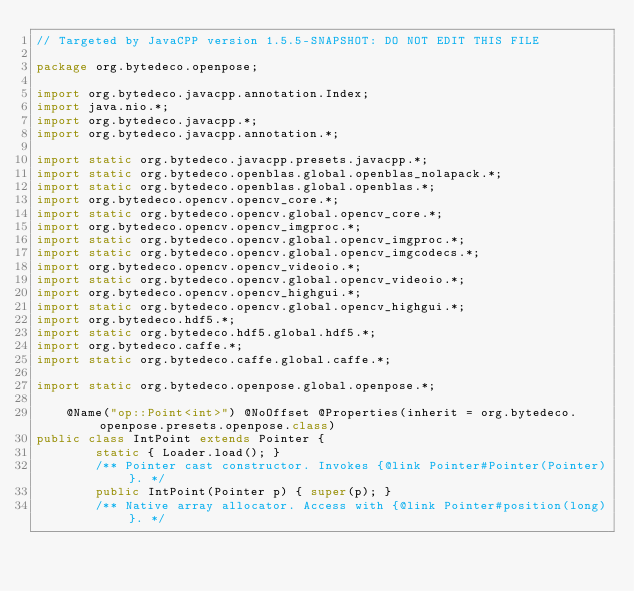Convert code to text. <code><loc_0><loc_0><loc_500><loc_500><_Java_>// Targeted by JavaCPP version 1.5.5-SNAPSHOT: DO NOT EDIT THIS FILE

package org.bytedeco.openpose;

import org.bytedeco.javacpp.annotation.Index;
import java.nio.*;
import org.bytedeco.javacpp.*;
import org.bytedeco.javacpp.annotation.*;

import static org.bytedeco.javacpp.presets.javacpp.*;
import static org.bytedeco.openblas.global.openblas_nolapack.*;
import static org.bytedeco.openblas.global.openblas.*;
import org.bytedeco.opencv.opencv_core.*;
import static org.bytedeco.opencv.global.opencv_core.*;
import org.bytedeco.opencv.opencv_imgproc.*;
import static org.bytedeco.opencv.global.opencv_imgproc.*;
import static org.bytedeco.opencv.global.opencv_imgcodecs.*;
import org.bytedeco.opencv.opencv_videoio.*;
import static org.bytedeco.opencv.global.opencv_videoio.*;
import org.bytedeco.opencv.opencv_highgui.*;
import static org.bytedeco.opencv.global.opencv_highgui.*;
import org.bytedeco.hdf5.*;
import static org.bytedeco.hdf5.global.hdf5.*;
import org.bytedeco.caffe.*;
import static org.bytedeco.caffe.global.caffe.*;

import static org.bytedeco.openpose.global.openpose.*;

    @Name("op::Point<int>") @NoOffset @Properties(inherit = org.bytedeco.openpose.presets.openpose.class)
public class IntPoint extends Pointer {
        static { Loader.load(); }
        /** Pointer cast constructor. Invokes {@link Pointer#Pointer(Pointer)}. */
        public IntPoint(Pointer p) { super(p); }
        /** Native array allocator. Access with {@link Pointer#position(long)}. */</code> 